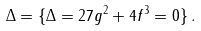Convert formula to latex. <formula><loc_0><loc_0><loc_500><loc_500>\Delta = \{ \Delta = 2 7 g ^ { 2 } + 4 f ^ { 3 } = 0 \} \, .</formula> 